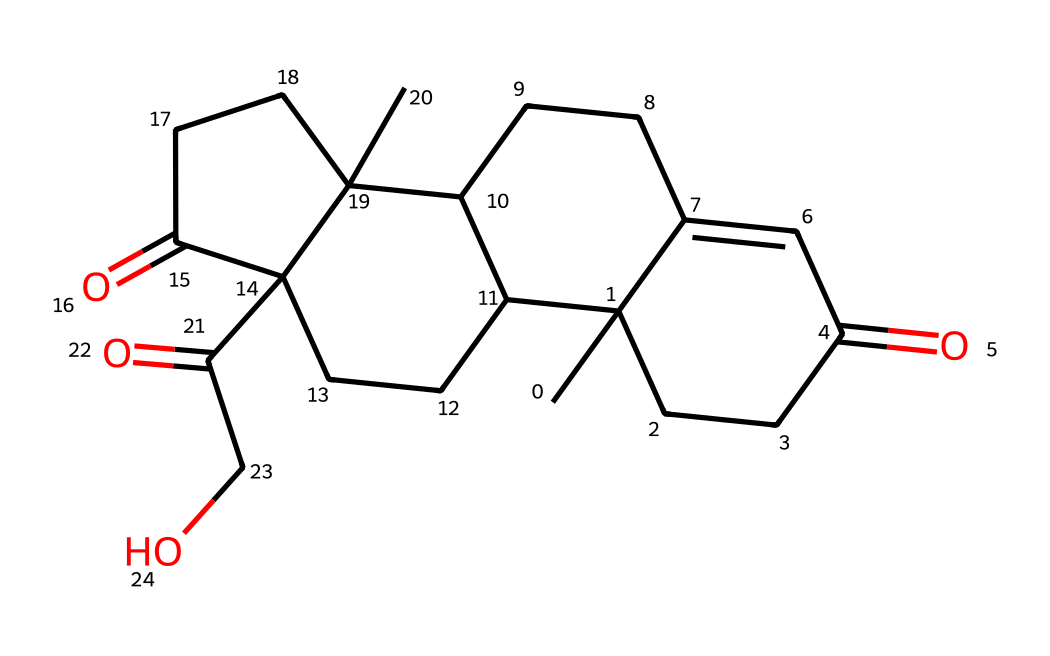What is the primary function of cortisol in the body? Cortisol is a steroid hormone primarily involved in the regulation of metabolism, immune response, and stress response. It helps in managing how the body utilizes carbohydrates, fats, and proteins, while also modulating inflammation.
Answer: stress hormone How many carbon atoms are present in the cortisol structure? By analyzing the SMILES representation, each segment indicates specific atoms; counting the occurrences of the carbon (C) symbol reveals there are 21 carbon atoms in cortisol.
Answer: 21 What type of chemical is cortisol classified as? The molecular structure contains a steroid nucleus and functional groups, which categorize it as a steroid hormone. Steroids are characterized by four fused carbon rings which cortisol exhibits.
Answer: steroid Which functional groups are evident in the cortisol structure? Upon examining the chemical structure, cortisol contains multiple functional groups: ketones and hydroxyl, indicated by the presence of (=O) and (OH) groups. These functional groups play roles in its biological activity.
Answer: ketones and hydroxyl What stereo-specific configuration does cortisol exhibit? The chemical structure displays multiple stereocenters, which are carbons connected to four different substituents, indicating that cortisol has specific stereochemistry, particularly important for its biological function as it affects receptor binding.
Answer: chiral 